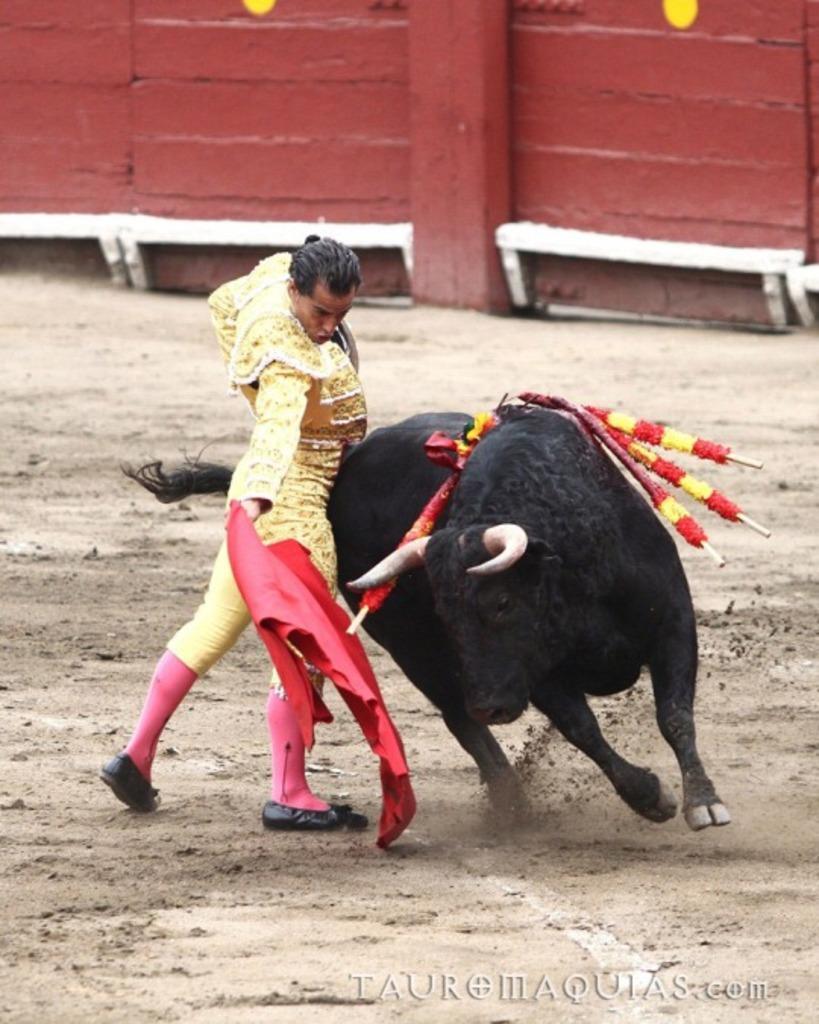Please provide a concise description of this image. This image is taken outdoors. At the bottom of the image there is a ground. In the background there is a wall. In the middle of the image a bull is running on the ground. A man is standing on the ground and he is holding a red colored cloth in his hand. 